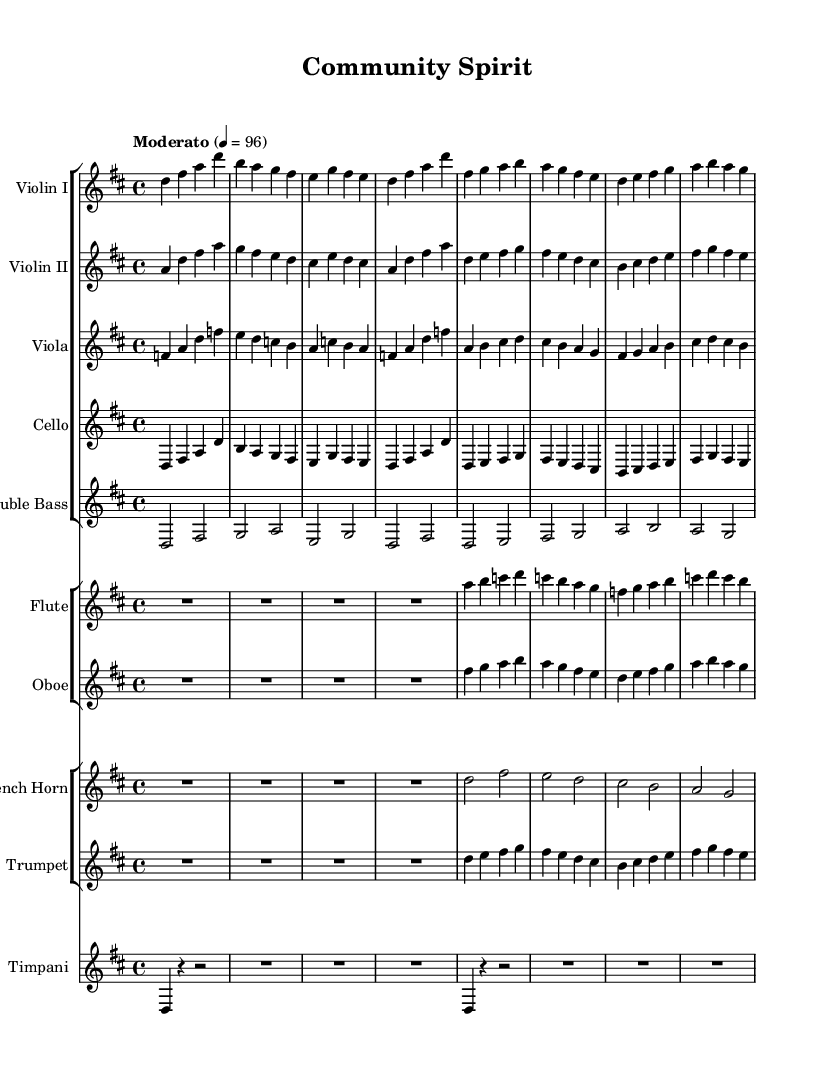What is the key signature of this music? The key signature is D major, indicated by two sharps on the staff.
Answer: D major What is the time signature of this score? The time signature is 4/4, represented as a fraction with a 4 on top and bottom in the beginning.
Answer: 4/4 What is the tempo marking of this composition? The tempo marking is "Moderato," which suggests a moderate speed for the piece, specifically indicated with the tempo of quarter note equals 96.
Answer: Moderato How many measures are there in the first violin part? By counting the measures on the staff for the first violin part, there are 8 measures present.
Answer: 8 Which instruments are present in the score? The score includes strings (Violin I, Violin II, Viola, Cello, Double Bass), woodwinds (Flute, Oboe), brass (French Horn, Trumpet), and percussion (Timpani).
Answer: Violin I, Violin II, Viola, Cello, Double Bass, Flute, Oboe, French Horn, Trumpet, Timpani What is the main theme represented through the orchestration of this piece? The orchestration blends strings and woodwinds to create an uplifting, harmonious sound, reflecting themes of community and personal growth, characteristic of soundtracks.
Answer: Community and personal growth What is the role of the timpani in this score? The timpani serves as a rhythmic foundation and accentuating color in this orchestral score, marking the downbeats and enhancing the overall theme of the music.
Answer: Rhythmic foundation 